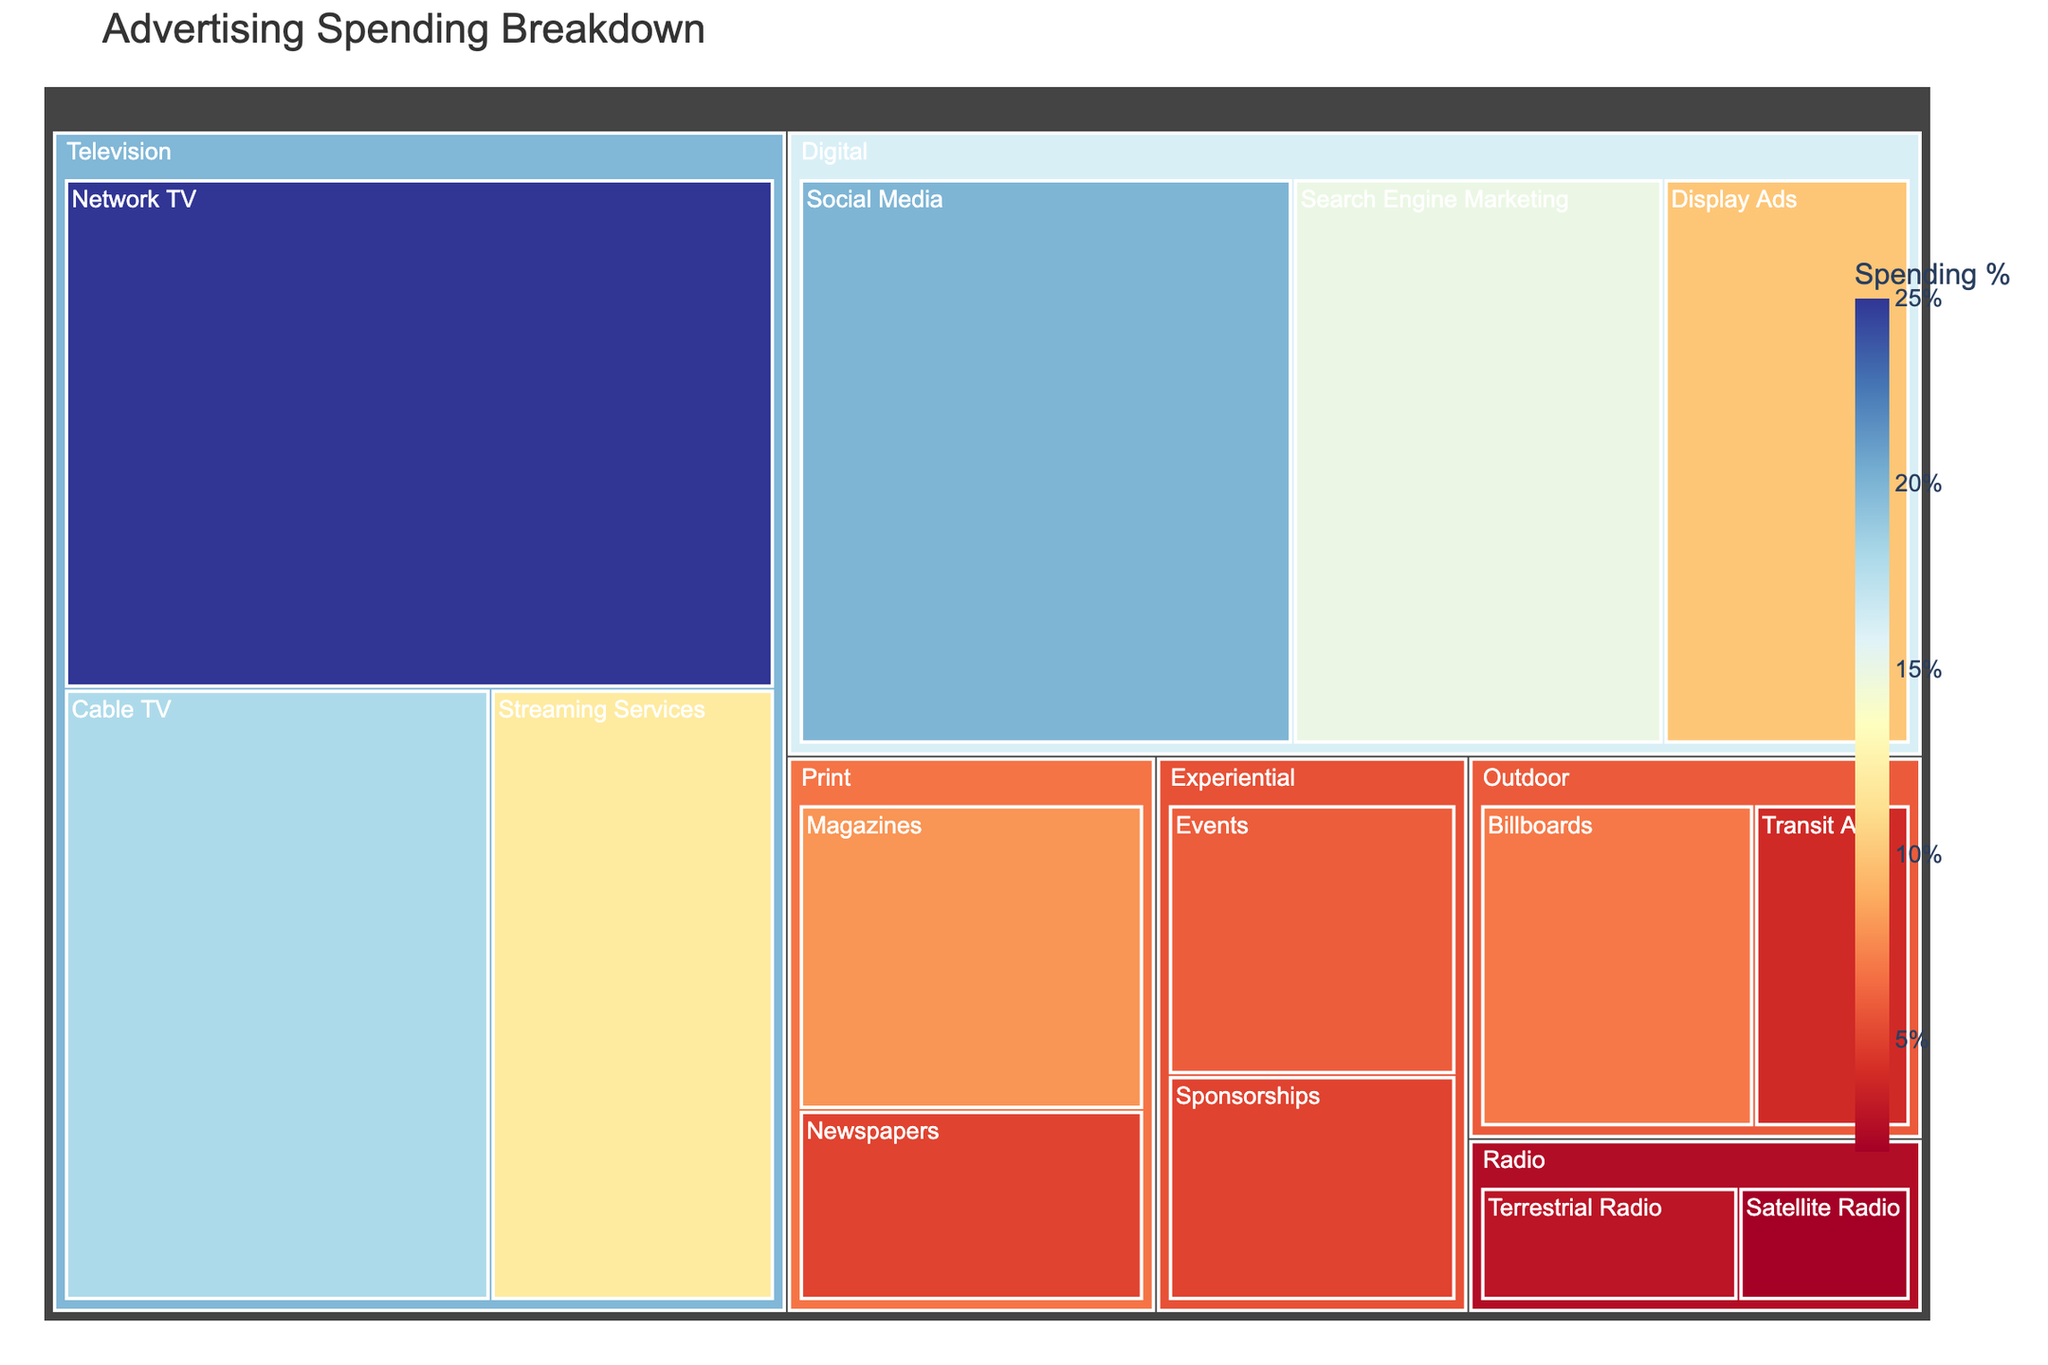What is the title of the Treemap? The title is usually placed at the top of the figure and is used to describe what the Treemap represents. Here, it's clearly indicated.
Answer: Advertising Spending Breakdown Which media channel has the highest advertising spending? Look for the largest tile in the Treemap. In this case, it’s the tile for "Network TV" under the "Television" category.
Answer: Network TV How much is spent on Social Media compared to Search Engine Marketing? Compare the sizes of the tiles for "Social Media" and "Search Engine Marketing" under the "Digital" category. "Social Media" has a value of 20%, while "Search Engine Marketing" has a value of 15%.
Answer: 20% vs. 15% What percentage of the total budget is spent on Print media? Sum the spending for "Magazines" and "Newspapers" within the "Print" category. Magazines (8%) + Newspapers (5%) = 13%.
Answer: 13% What is the combined advertising spend on terrestrial and satellite radio channels? Add the values of "Terrestrial Radio" and "Satellite Radio" under the "Radio" category. Terrestrial Radio (3%) + Satellite Radio (2%) = 5%.
Answer: 5% Which subcategory has the smallest spending, and how much is it? Identify the smallest tile in the Treemap, which is "Satellite Radio" at 2%.
Answer: Satellite Radio, 2% How does the spending on Experiential marketing compare to Outdoor advertising? Add up the values for the subcategories under "Experiential" (Events 6%, Sponsorships 5%) and "Outdoor" (Billboards 7%, Transit Ads 4%). Experiential: 6% + 5% = 11%, Outdoor: 7% + 4% = 11%.
Answer: Both are 11% What is the total spending on Digital media? Add the values for the subcategories under "Digital" (Social Media 20%, Search Engine Marketing 15%, Display Ads 10%). Social Media (20%) + Search Engine Marketing (15%) + Display Ads (10%) = 45%.
Answer: 45% Which has more spending: Cable TV or all Radio combined? Compare the value of "Cable TV" (18%) with the sum of "Terrestrial Radio" and "Satellite Radio" (3% + 2% = 5%).
Answer: Cable TV What is the difference in spending between streaming services and billboards? Subtract the value of "Billboards" (7%) from "Streaming Services" (12%). 12% - 7% = 5%.
Answer: 5% 